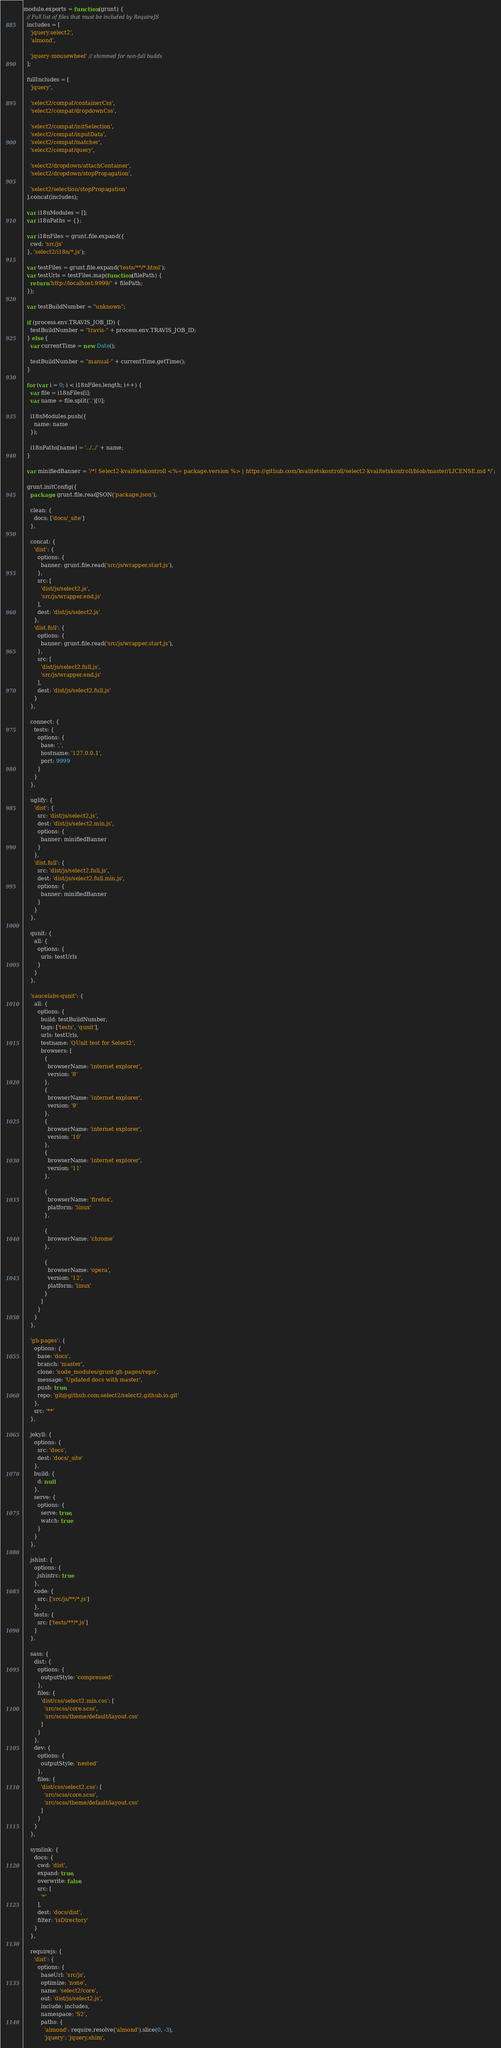Convert code to text. <code><loc_0><loc_0><loc_500><loc_500><_JavaScript_>module.exports = function (grunt) {
  // Full list of files that must be included by RequireJS
  includes = [
    'jquery.select2',
    'almond',

    'jquery-mousewheel' // shimmed for non-full builds
  ];

  fullIncludes = [
    'jquery',

    'select2/compat/containerCss',
    'select2/compat/dropdownCss',

    'select2/compat/initSelection',
    'select2/compat/inputData',
    'select2/compat/matcher',
    'select2/compat/query',

    'select2/dropdown/attachContainer',
    'select2/dropdown/stopPropagation',

    'select2/selection/stopPropagation'
  ].concat(includes);

  var i18nModules = [];
  var i18nPaths = {};

  var i18nFiles = grunt.file.expand({
    cwd: 'src/js'
  }, 'select2/i18n/*.js');

  var testFiles = grunt.file.expand('tests/**/*.html');
  var testUrls = testFiles.map(function (filePath) {
    return 'http://localhost:9999/' + filePath;
  });

  var testBuildNumber = "unknown";

  if (process.env.TRAVIS_JOB_ID) {
    testBuildNumber = "travis-" + process.env.TRAVIS_JOB_ID;
  } else {
    var currentTime = new Date();

    testBuildNumber = "manual-" + currentTime.getTime();
  }

  for (var i = 0; i < i18nFiles.length; i++) {
    var file = i18nFiles[i];
    var name = file.split('.')[0];

    i18nModules.push({
      name: name
    });

    i18nPaths[name] = '../../' + name;
  }

  var minifiedBanner = '/*! Select2-kvalitetskontroll <%= package.version %> | https://github.com/kvalitetskontroll/select2-kvalitetskontroll/blob/master/LICENSE.md */';

  grunt.initConfig({
    package: grunt.file.readJSON('package.json'),

    clean: {
      docs: ['docs/_site']
    },

    concat: {
      'dist': {
        options: {
          banner: grunt.file.read('src/js/wrapper.start.js'),
        },
        src: [
          'dist/js/select2.js',
          'src/js/wrapper.end.js'
        ],
        dest: 'dist/js/select2.js'
      },
      'dist.full': {
        options: {
          banner: grunt.file.read('src/js/wrapper.start.js'),
        },
        src: [
          'dist/js/select2.full.js',
          'src/js/wrapper.end.js'
        ],
        dest: 'dist/js/select2.full.js'
      }
    },

    connect: {
      tests: {
        options: {
          base: '.',
          hostname: '127.0.0.1',
          port: 9999
        }
      }
    },

    uglify: {
      'dist': {
        src: 'dist/js/select2.js',
        dest: 'dist/js/select2.min.js',
        options: {
          banner: minifiedBanner
        }
      },
      'dist.full': {
        src: 'dist/js/select2.full.js',
        dest: 'dist/js/select2.full.min.js',
        options: {
          banner: minifiedBanner
        }
      }
    },

    qunit: {
      all: {
        options: {
          urls: testUrls
        }
      }
    },

    'saucelabs-qunit': {
      all: {
        options: {
          build: testBuildNumber,
          tags: ['tests', 'qunit'],
          urls: testUrls,
          testname: 'QUnit test for Select2',
          browsers: [
            {
              browserName: 'internet explorer',
              version: '8'
            },
            {
              browserName: 'internet explorer',
              version: '9'
            },
            {
              browserName: 'internet explorer',
              version: '10'
            },
            {
              browserName: 'internet explorer',
              version: '11'
            },

            {
              browserName: 'firefox',
              platform: 'linux'
            },

            {
              browserName: 'chrome'
            },

            {
              browserName: 'opera',
              version: '12',
              platform: 'linux'
            }
          ]
        }
      }
    },

    'gh-pages': {
      options: {
        base: 'docs',
        branch: 'master',
        clone: 'node_modules/grunt-gh-pages/repo',
        message: 'Updated docs with master',
        push: true,
        repo: 'git@github.com:select2/select2.github.io.git'
      },
      src: '**'
    },

    jekyll: {
      options: {
        src: 'docs',
        dest: 'docs/_site'
      },
      build: {
        d: null
      },
      serve: {
        options: {
          serve: true,
          watch: true
        }
      }
    },

    jshint: {
      options: {
        jshintrc: true
      },
      code: {
        src: ['src/js/**/*.js']
      },
      tests: {
        src: ['tests/**/*.js']
      }
    },

    sass: {
      dist: {
        options: {
          outputStyle: 'compressed'
        },
        files: {
          'dist/css/select2.min.css': [
            'src/scss/core.scss',
            'src/scss/theme/default/layout.css'
          ]
        }
      },
      dev: {
        options: {
          outputStyle: 'nested'
        },
        files: {
          'dist/css/select2.css': [
            'src/scss/core.scss',
            'src/scss/theme/default/layout.css'
          ]
        }
      }
    },

    symlink: {
      docs: {
        cwd: 'dist',
        expand: true,
        overwrite: false,
        src: [
          '*'
        ],
        dest: 'docs/dist',
        filter: 'isDirectory'
      }
    },

    requirejs: {
      'dist': {
        options: {
          baseUrl: 'src/js',
          optimize: 'none',
          name: 'select2/core',
          out: 'dist/js/select2.js',
          include: includes,
          namespace: 'S2',
          paths: {
            'almond': require.resolve('almond').slice(0, -3),
            'jquery': 'jquery.shim',</code> 